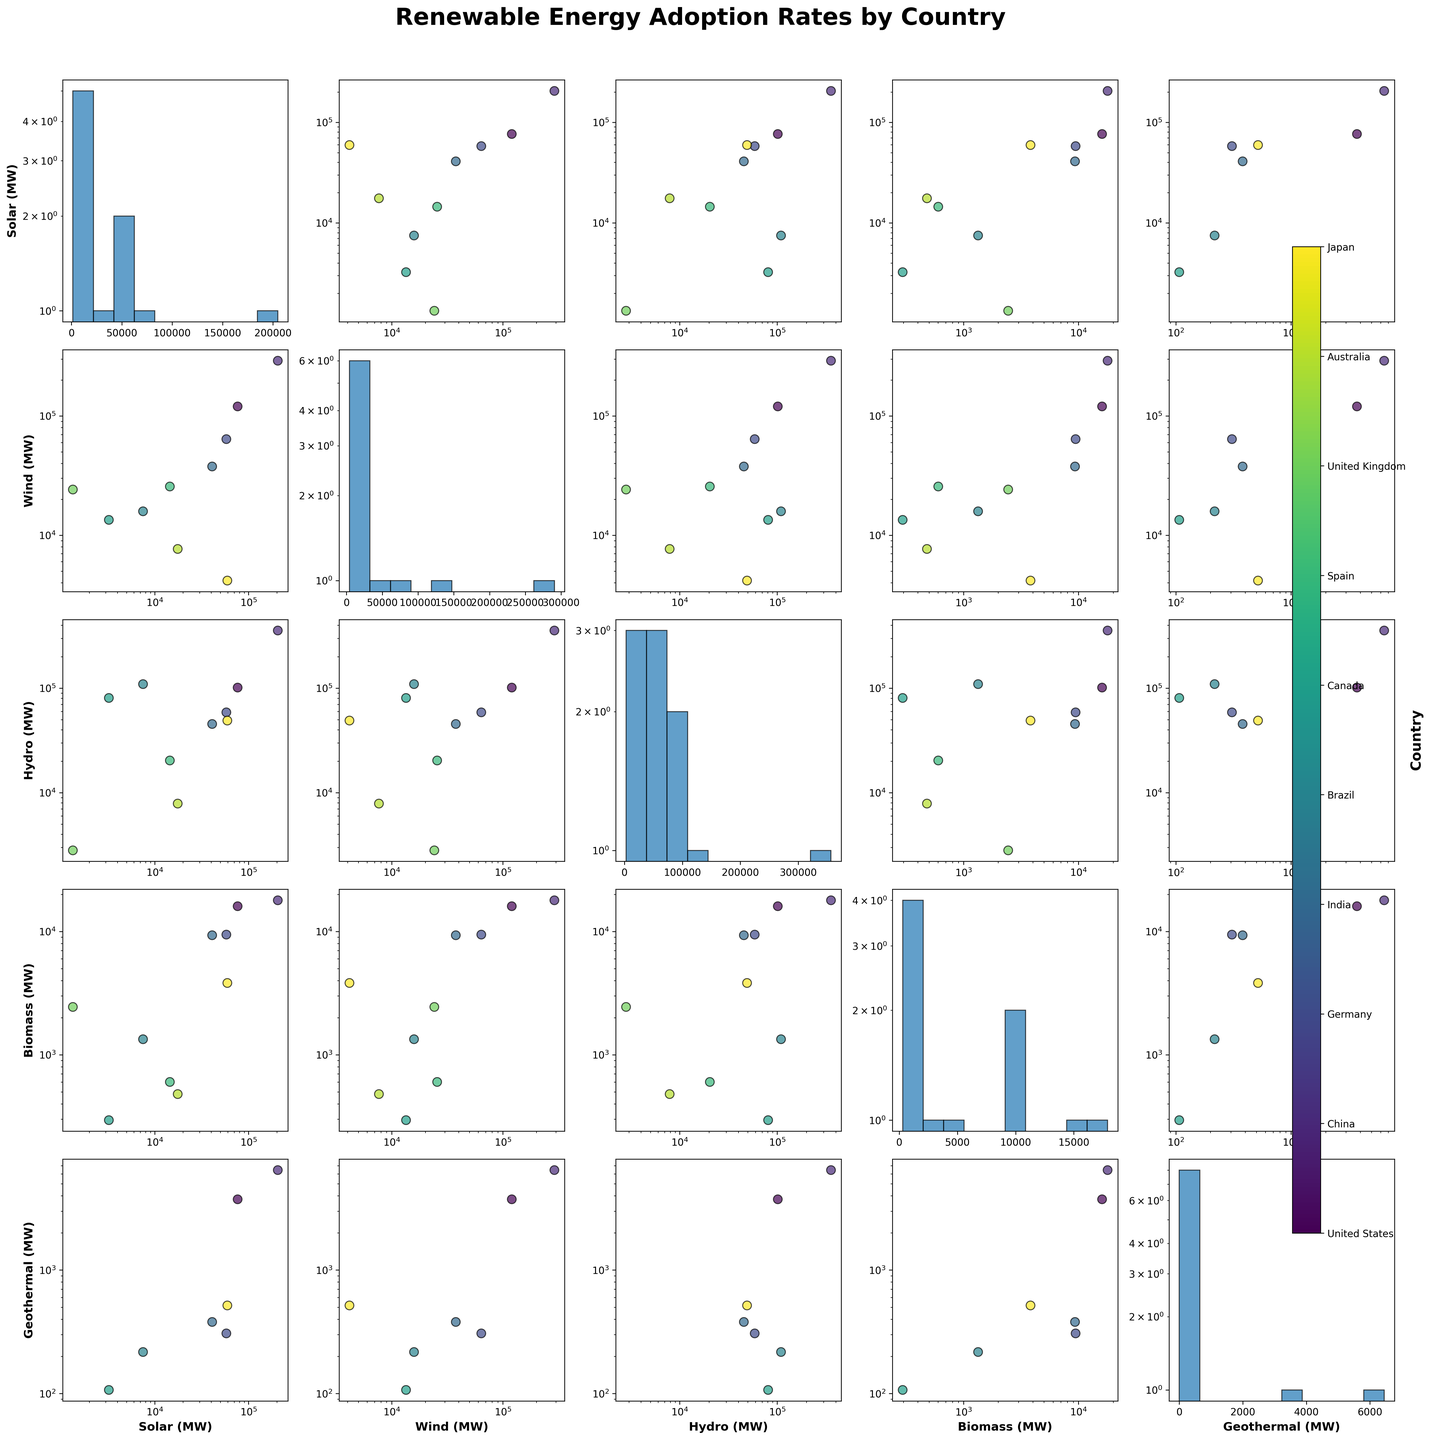How many countries are included in the SPLOM? Look at the number of entries in the color bar that represents the countries. There is a list of country names in the color bar. Count them.
Answer: 10 What is the title of the figure? The title is usually placed at the top of the figure, it's easy to spot. For this figure, the title reads "Renewable Energy Adoption Rates by Country".
Answer: Renewable Energy Adoption Rates by Country Which country has the highest solar power adoption? Look at the axis labeled "Solar (MW)" across multiple scatter plots. The highest value point on this axis represents the country with the highest solar power adoption. Use the color of the data point to relate it back to the country in the color bar.
Answer: China Which country has the lowest hydro power adoption? Locate the axis labeled "Hydro (MW)" in the scatter plots. Identify the smallest value and match its color with the corresponding country in the color bar.
Answer: United Kingdom Between solar and wind power, which energy source generally has higher adoption rates on average? Compare the density and spread of the data points in the plots for "Solar (MW)" and "Wind (MW)". Solar shows larger values and a wider range of adoption.
Answer: Wind What is the typical range of geothermal power adoption across countries? Look at the axis labeled "Geothermal (MW)". Pay attention to the spread of the points. Observe that most values are concentrated between 0 and 1,000 MW.
Answer: 0 to 6,447 MW How does the solar power adoption in Brazil compare to Canada? Focus on the scatter plots where one axis is "Solar (MW)". Locate the points for Brazil and Canada. Brazil's is slightly higher based on the vertical position in the graph.
Answer: Brazil has higher solar power adoption than Canada By visual inspection, what can be inferred about the correlation between wind and hydro power adoption? Look at the scatter plot with "Wind (MW)" on one axis and "Hydro (MW)" on the other. The spread of points will help you assess whether there's a positive, negative, or no correlation.
Answer: Generally positive correlation Which energy source shows the least variation in adoption rates across countries? Identify the axis where points are the most bunched together, indicating less variation. From the axes, geothermal shows the least spread.
Answer: Geothermal What is the overall trend of biomass adoption compared to other energy sources? Observe the scatter plots that involve biomass. Biomass points are typically on the lower end and are clustered tightly, indicating it has lower and less variable adoption rates.
Answer: Lower and less variable 